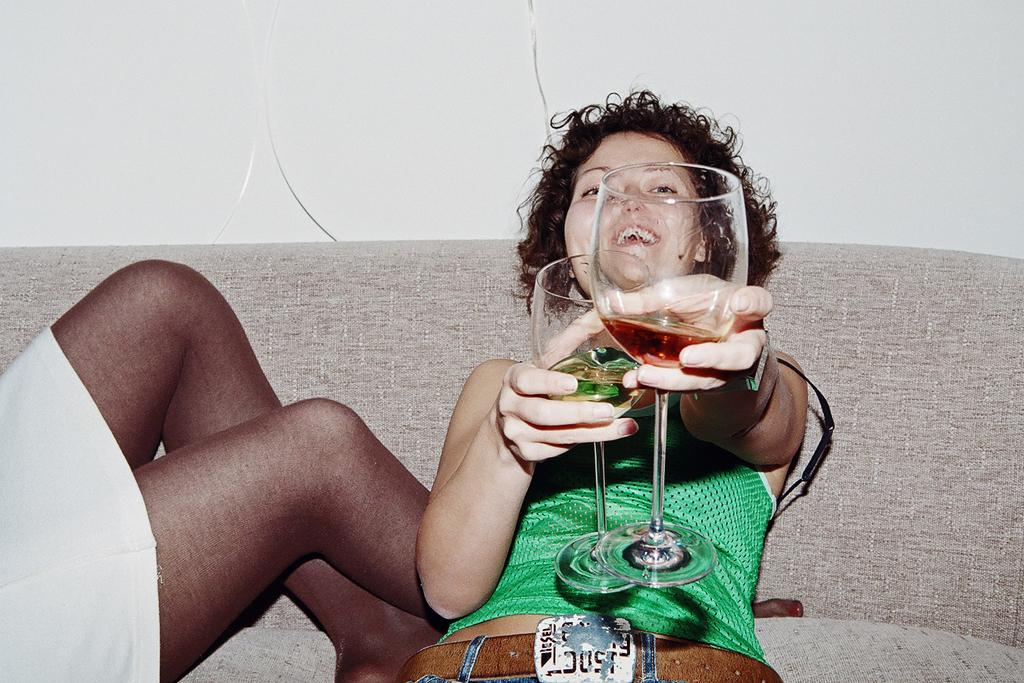What is the girl in the image doing? The girl is sitting on the sofa in the image. What is the girl holding in her hands? The girl is holding glasses in her hands. Can you describe the other person in the image? There is another person on the left side of the image. What type of pet is sitting next to the girl on the sofa? There is no pet visible in the image. 